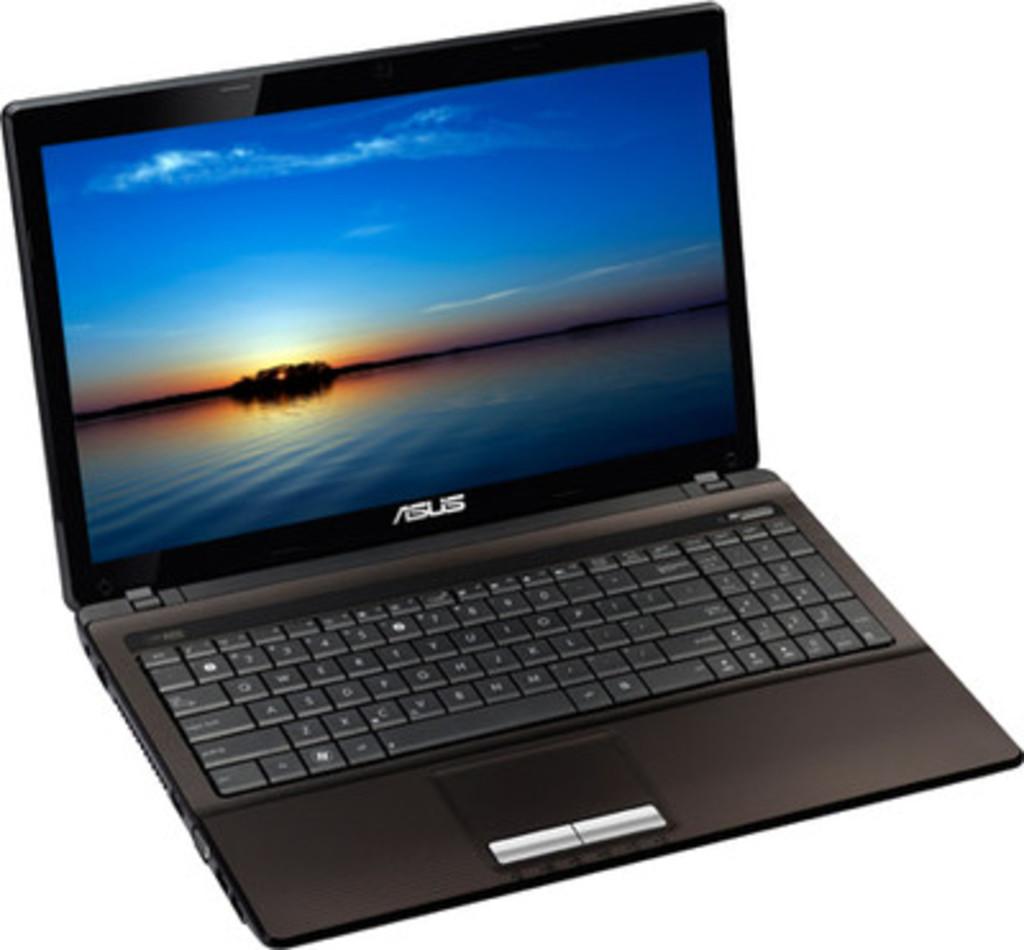The writing is not clear to read, what does it say?
Ensure brevity in your answer.  Asus. What brand of laptop is this?
Your answer should be compact. Asus. 